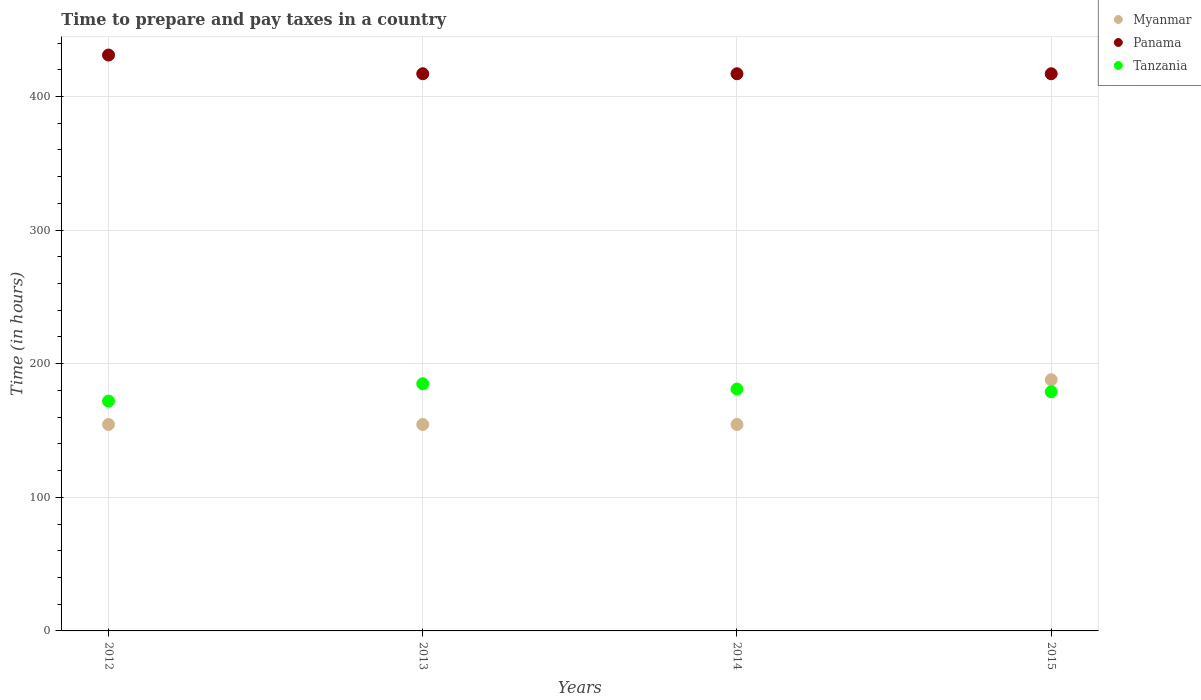Is the number of dotlines equal to the number of legend labels?
Ensure brevity in your answer.  Yes. What is the number of hours required to prepare and pay taxes in Tanzania in 2012?
Keep it short and to the point. 172. Across all years, what is the maximum number of hours required to prepare and pay taxes in Myanmar?
Keep it short and to the point. 188. Across all years, what is the minimum number of hours required to prepare and pay taxes in Tanzania?
Your response must be concise. 172. In which year was the number of hours required to prepare and pay taxes in Panama maximum?
Keep it short and to the point. 2012. What is the total number of hours required to prepare and pay taxes in Tanzania in the graph?
Give a very brief answer. 717. What is the difference between the number of hours required to prepare and pay taxes in Panama in 2012 and that in 2013?
Offer a very short reply. 14. What is the difference between the number of hours required to prepare and pay taxes in Myanmar in 2014 and the number of hours required to prepare and pay taxes in Tanzania in 2012?
Give a very brief answer. -17.5. What is the average number of hours required to prepare and pay taxes in Panama per year?
Keep it short and to the point. 420.5. In the year 2014, what is the difference between the number of hours required to prepare and pay taxes in Tanzania and number of hours required to prepare and pay taxes in Panama?
Make the answer very short. -236. In how many years, is the number of hours required to prepare and pay taxes in Panama greater than 120 hours?
Your response must be concise. 4. Is the difference between the number of hours required to prepare and pay taxes in Tanzania in 2013 and 2014 greater than the difference between the number of hours required to prepare and pay taxes in Panama in 2013 and 2014?
Offer a terse response. Yes. What is the difference between the highest and the second highest number of hours required to prepare and pay taxes in Myanmar?
Your answer should be very brief. 33.5. What is the difference between the highest and the lowest number of hours required to prepare and pay taxes in Panama?
Provide a succinct answer. 14. In how many years, is the number of hours required to prepare and pay taxes in Panama greater than the average number of hours required to prepare and pay taxes in Panama taken over all years?
Keep it short and to the point. 1. Is the sum of the number of hours required to prepare and pay taxes in Myanmar in 2014 and 2015 greater than the maximum number of hours required to prepare and pay taxes in Tanzania across all years?
Your answer should be very brief. Yes. Is it the case that in every year, the sum of the number of hours required to prepare and pay taxes in Myanmar and number of hours required to prepare and pay taxes in Tanzania  is greater than the number of hours required to prepare and pay taxes in Panama?
Make the answer very short. No. Does the number of hours required to prepare and pay taxes in Tanzania monotonically increase over the years?
Keep it short and to the point. No. Is the number of hours required to prepare and pay taxes in Tanzania strictly less than the number of hours required to prepare and pay taxes in Myanmar over the years?
Your response must be concise. No. How many dotlines are there?
Ensure brevity in your answer.  3. How are the legend labels stacked?
Your answer should be compact. Vertical. What is the title of the graph?
Offer a very short reply. Time to prepare and pay taxes in a country. What is the label or title of the X-axis?
Your response must be concise. Years. What is the label or title of the Y-axis?
Ensure brevity in your answer.  Time (in hours). What is the Time (in hours) of Myanmar in 2012?
Offer a very short reply. 154.5. What is the Time (in hours) of Panama in 2012?
Your answer should be compact. 431. What is the Time (in hours) of Tanzania in 2012?
Provide a succinct answer. 172. What is the Time (in hours) in Myanmar in 2013?
Provide a short and direct response. 154.5. What is the Time (in hours) of Panama in 2013?
Make the answer very short. 417. What is the Time (in hours) in Tanzania in 2013?
Offer a very short reply. 185. What is the Time (in hours) in Myanmar in 2014?
Keep it short and to the point. 154.5. What is the Time (in hours) in Panama in 2014?
Provide a succinct answer. 417. What is the Time (in hours) of Tanzania in 2014?
Offer a terse response. 181. What is the Time (in hours) in Myanmar in 2015?
Give a very brief answer. 188. What is the Time (in hours) in Panama in 2015?
Your answer should be very brief. 417. What is the Time (in hours) in Tanzania in 2015?
Give a very brief answer. 179. Across all years, what is the maximum Time (in hours) in Myanmar?
Offer a very short reply. 188. Across all years, what is the maximum Time (in hours) of Panama?
Provide a short and direct response. 431. Across all years, what is the maximum Time (in hours) in Tanzania?
Your answer should be compact. 185. Across all years, what is the minimum Time (in hours) of Myanmar?
Make the answer very short. 154.5. Across all years, what is the minimum Time (in hours) in Panama?
Provide a short and direct response. 417. Across all years, what is the minimum Time (in hours) of Tanzania?
Give a very brief answer. 172. What is the total Time (in hours) of Myanmar in the graph?
Make the answer very short. 651.5. What is the total Time (in hours) of Panama in the graph?
Your answer should be compact. 1682. What is the total Time (in hours) in Tanzania in the graph?
Your answer should be compact. 717. What is the difference between the Time (in hours) of Myanmar in 2012 and that in 2013?
Offer a very short reply. 0. What is the difference between the Time (in hours) of Tanzania in 2012 and that in 2013?
Your answer should be very brief. -13. What is the difference between the Time (in hours) in Myanmar in 2012 and that in 2014?
Offer a very short reply. 0. What is the difference between the Time (in hours) of Panama in 2012 and that in 2014?
Make the answer very short. 14. What is the difference between the Time (in hours) of Myanmar in 2012 and that in 2015?
Offer a very short reply. -33.5. What is the difference between the Time (in hours) of Panama in 2012 and that in 2015?
Offer a very short reply. 14. What is the difference between the Time (in hours) of Tanzania in 2012 and that in 2015?
Give a very brief answer. -7. What is the difference between the Time (in hours) of Myanmar in 2013 and that in 2014?
Your answer should be very brief. 0. What is the difference between the Time (in hours) in Myanmar in 2013 and that in 2015?
Ensure brevity in your answer.  -33.5. What is the difference between the Time (in hours) of Tanzania in 2013 and that in 2015?
Offer a terse response. 6. What is the difference between the Time (in hours) in Myanmar in 2014 and that in 2015?
Your response must be concise. -33.5. What is the difference between the Time (in hours) of Panama in 2014 and that in 2015?
Make the answer very short. 0. What is the difference between the Time (in hours) in Tanzania in 2014 and that in 2015?
Make the answer very short. 2. What is the difference between the Time (in hours) in Myanmar in 2012 and the Time (in hours) in Panama in 2013?
Your answer should be very brief. -262.5. What is the difference between the Time (in hours) of Myanmar in 2012 and the Time (in hours) of Tanzania in 2013?
Your answer should be very brief. -30.5. What is the difference between the Time (in hours) in Panama in 2012 and the Time (in hours) in Tanzania in 2013?
Ensure brevity in your answer.  246. What is the difference between the Time (in hours) in Myanmar in 2012 and the Time (in hours) in Panama in 2014?
Keep it short and to the point. -262.5. What is the difference between the Time (in hours) of Myanmar in 2012 and the Time (in hours) of Tanzania in 2014?
Make the answer very short. -26.5. What is the difference between the Time (in hours) of Panama in 2012 and the Time (in hours) of Tanzania in 2014?
Ensure brevity in your answer.  250. What is the difference between the Time (in hours) in Myanmar in 2012 and the Time (in hours) in Panama in 2015?
Provide a short and direct response. -262.5. What is the difference between the Time (in hours) in Myanmar in 2012 and the Time (in hours) in Tanzania in 2015?
Your response must be concise. -24.5. What is the difference between the Time (in hours) of Panama in 2012 and the Time (in hours) of Tanzania in 2015?
Offer a very short reply. 252. What is the difference between the Time (in hours) in Myanmar in 2013 and the Time (in hours) in Panama in 2014?
Your answer should be very brief. -262.5. What is the difference between the Time (in hours) in Myanmar in 2013 and the Time (in hours) in Tanzania in 2014?
Make the answer very short. -26.5. What is the difference between the Time (in hours) of Panama in 2013 and the Time (in hours) of Tanzania in 2014?
Your response must be concise. 236. What is the difference between the Time (in hours) of Myanmar in 2013 and the Time (in hours) of Panama in 2015?
Offer a very short reply. -262.5. What is the difference between the Time (in hours) of Myanmar in 2013 and the Time (in hours) of Tanzania in 2015?
Your answer should be very brief. -24.5. What is the difference between the Time (in hours) in Panama in 2013 and the Time (in hours) in Tanzania in 2015?
Offer a very short reply. 238. What is the difference between the Time (in hours) in Myanmar in 2014 and the Time (in hours) in Panama in 2015?
Provide a succinct answer. -262.5. What is the difference between the Time (in hours) of Myanmar in 2014 and the Time (in hours) of Tanzania in 2015?
Keep it short and to the point. -24.5. What is the difference between the Time (in hours) in Panama in 2014 and the Time (in hours) in Tanzania in 2015?
Keep it short and to the point. 238. What is the average Time (in hours) in Myanmar per year?
Ensure brevity in your answer.  162.88. What is the average Time (in hours) of Panama per year?
Your response must be concise. 420.5. What is the average Time (in hours) in Tanzania per year?
Provide a short and direct response. 179.25. In the year 2012, what is the difference between the Time (in hours) of Myanmar and Time (in hours) of Panama?
Your answer should be compact. -276.5. In the year 2012, what is the difference between the Time (in hours) of Myanmar and Time (in hours) of Tanzania?
Offer a very short reply. -17.5. In the year 2012, what is the difference between the Time (in hours) of Panama and Time (in hours) of Tanzania?
Offer a terse response. 259. In the year 2013, what is the difference between the Time (in hours) in Myanmar and Time (in hours) in Panama?
Provide a short and direct response. -262.5. In the year 2013, what is the difference between the Time (in hours) in Myanmar and Time (in hours) in Tanzania?
Your answer should be very brief. -30.5. In the year 2013, what is the difference between the Time (in hours) of Panama and Time (in hours) of Tanzania?
Offer a very short reply. 232. In the year 2014, what is the difference between the Time (in hours) of Myanmar and Time (in hours) of Panama?
Keep it short and to the point. -262.5. In the year 2014, what is the difference between the Time (in hours) of Myanmar and Time (in hours) of Tanzania?
Ensure brevity in your answer.  -26.5. In the year 2014, what is the difference between the Time (in hours) in Panama and Time (in hours) in Tanzania?
Your answer should be compact. 236. In the year 2015, what is the difference between the Time (in hours) of Myanmar and Time (in hours) of Panama?
Ensure brevity in your answer.  -229. In the year 2015, what is the difference between the Time (in hours) in Panama and Time (in hours) in Tanzania?
Provide a short and direct response. 238. What is the ratio of the Time (in hours) of Panama in 2012 to that in 2013?
Offer a terse response. 1.03. What is the ratio of the Time (in hours) of Tanzania in 2012 to that in 2013?
Ensure brevity in your answer.  0.93. What is the ratio of the Time (in hours) of Myanmar in 2012 to that in 2014?
Ensure brevity in your answer.  1. What is the ratio of the Time (in hours) of Panama in 2012 to that in 2014?
Your answer should be very brief. 1.03. What is the ratio of the Time (in hours) of Tanzania in 2012 to that in 2014?
Your response must be concise. 0.95. What is the ratio of the Time (in hours) of Myanmar in 2012 to that in 2015?
Your response must be concise. 0.82. What is the ratio of the Time (in hours) in Panama in 2012 to that in 2015?
Make the answer very short. 1.03. What is the ratio of the Time (in hours) of Tanzania in 2012 to that in 2015?
Your answer should be compact. 0.96. What is the ratio of the Time (in hours) of Myanmar in 2013 to that in 2014?
Offer a very short reply. 1. What is the ratio of the Time (in hours) in Panama in 2013 to that in 2014?
Your answer should be very brief. 1. What is the ratio of the Time (in hours) of Tanzania in 2013 to that in 2014?
Keep it short and to the point. 1.02. What is the ratio of the Time (in hours) in Myanmar in 2013 to that in 2015?
Your answer should be compact. 0.82. What is the ratio of the Time (in hours) of Tanzania in 2013 to that in 2015?
Your response must be concise. 1.03. What is the ratio of the Time (in hours) in Myanmar in 2014 to that in 2015?
Your answer should be very brief. 0.82. What is the ratio of the Time (in hours) in Tanzania in 2014 to that in 2015?
Keep it short and to the point. 1.01. What is the difference between the highest and the second highest Time (in hours) of Myanmar?
Make the answer very short. 33.5. What is the difference between the highest and the lowest Time (in hours) in Myanmar?
Make the answer very short. 33.5. What is the difference between the highest and the lowest Time (in hours) in Panama?
Give a very brief answer. 14. What is the difference between the highest and the lowest Time (in hours) in Tanzania?
Provide a short and direct response. 13. 